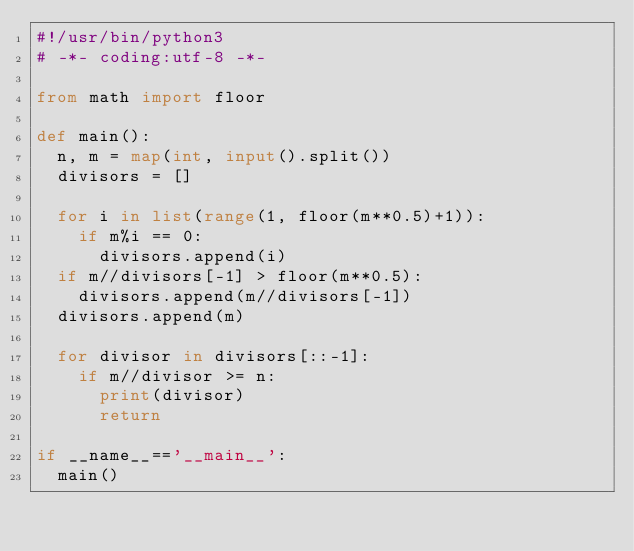<code> <loc_0><loc_0><loc_500><loc_500><_Python_>#!/usr/bin/python3
# -*- coding:utf-8 -*-

from math import floor

def main():
  n, m = map(int, input().split())
  divisors = []
  
  for i in list(range(1, floor(m**0.5)+1)):
    if m%i == 0:
      divisors.append(i)    
  if m//divisors[-1] > floor(m**0.5):
    divisors.append(m//divisors[-1])
  divisors.append(m)
  
  for divisor in divisors[::-1]:
    if m//divisor >= n:
      print(divisor)
      return
    
if __name__=='__main__':
  main()

</code> 